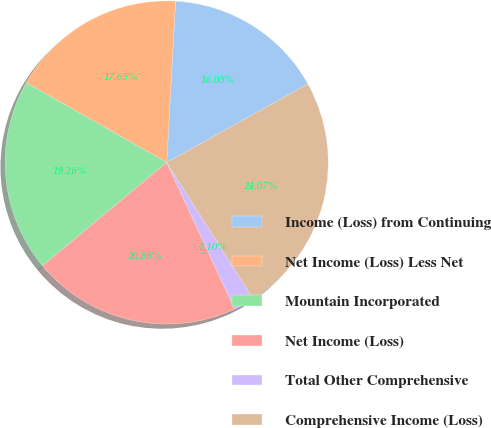Convert chart. <chart><loc_0><loc_0><loc_500><loc_500><pie_chart><fcel>Income (Loss) from Continuing<fcel>Net Income (Loss) Less Net<fcel>Mountain Incorporated<fcel>Net Income (Loss)<fcel>Total Other Comprehensive<fcel>Comprehensive Income (Loss)<nl><fcel>16.05%<fcel>17.65%<fcel>19.26%<fcel>20.86%<fcel>2.1%<fcel>24.07%<nl></chart> 